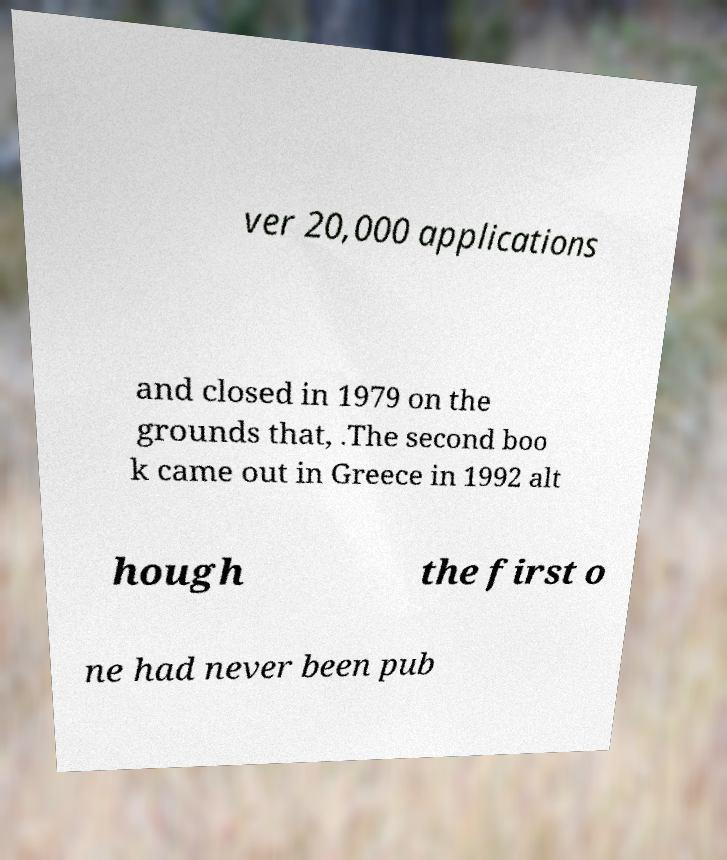What messages or text are displayed in this image? I need them in a readable, typed format. ver 20,000 applications and closed in 1979 on the grounds that, .The second boo k came out in Greece in 1992 alt hough the first o ne had never been pub 